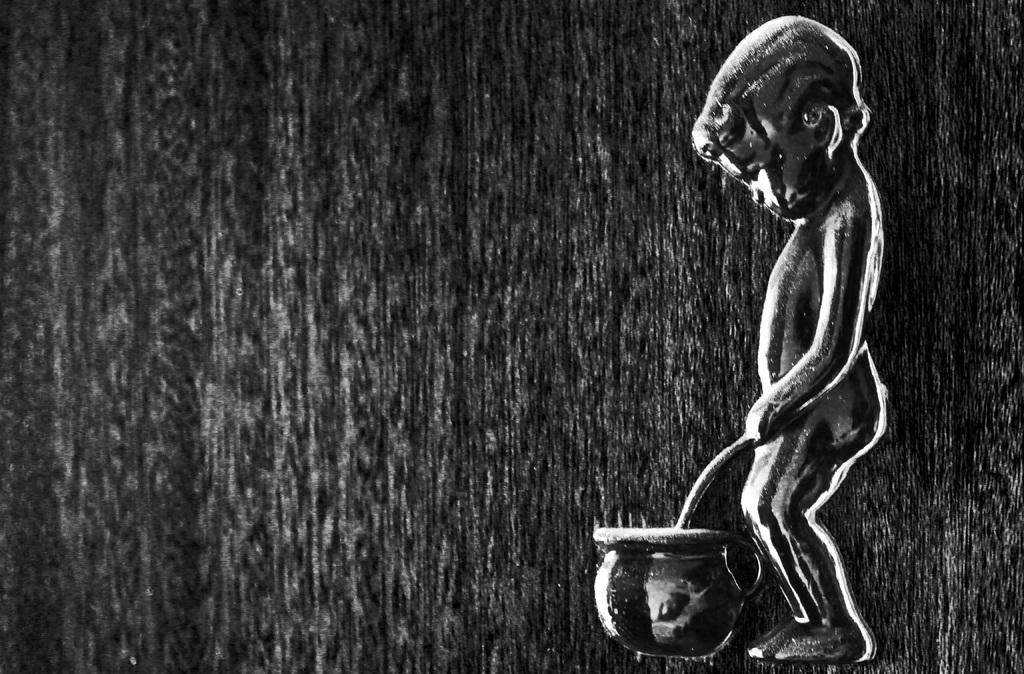What is the main subject of the image? There is a person standing in the image. What object can be seen in the image besides the person? There is a jar in the image. What type of pie is being served on the lamp in the image? There is no pie or lamp present in the image; it only features a person and a jar. 